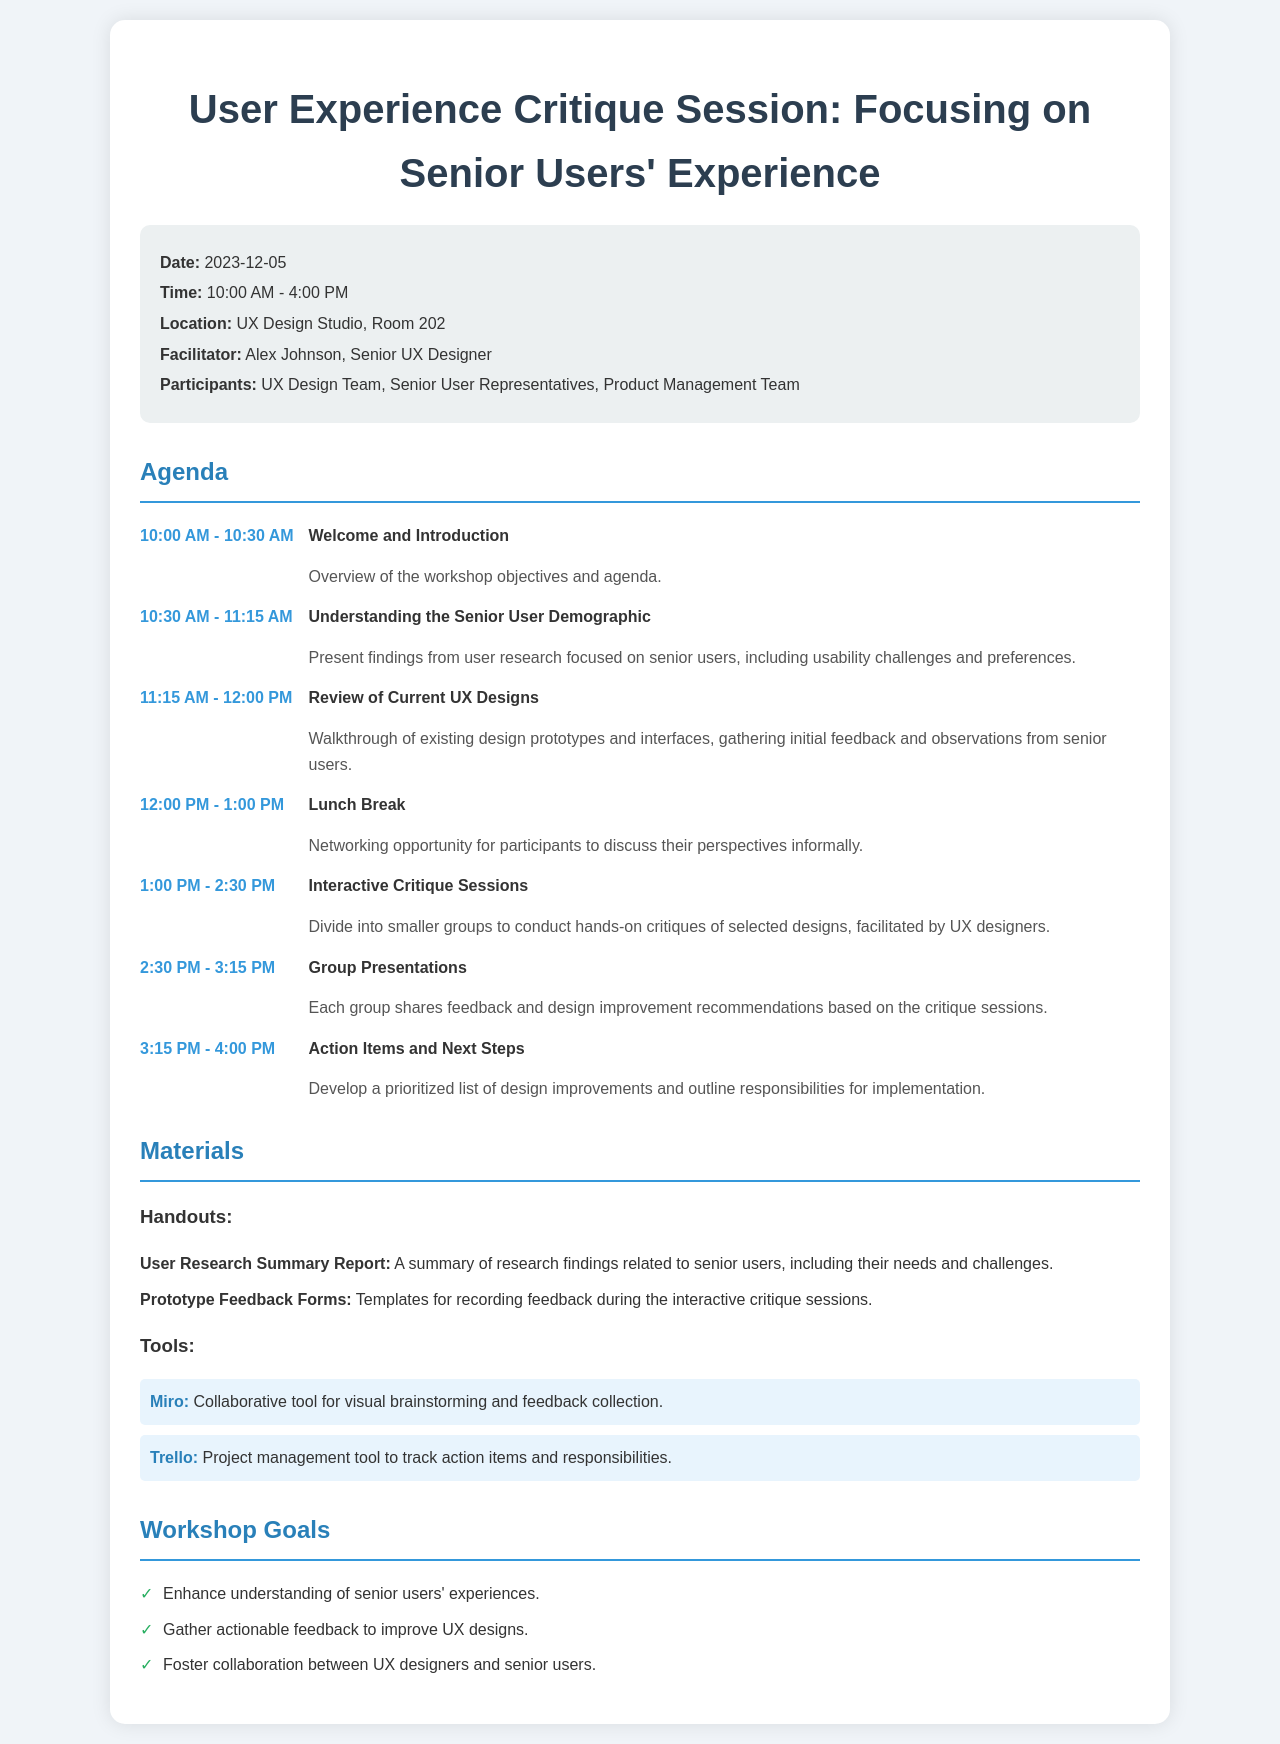what is the date of the workshop? The date of the workshop is explicitly stated in the document.
Answer: 2023-12-05 who is the facilitator of the workshop? The facilitator's name is provided within the workshop information section.
Answer: Alex Johnson what time does the workshop start? The start time of the workshop is mentioned along with the date in the document.
Answer: 10:00 AM what is the location of the workshop? The location details are outlined in the workshop information section.
Answer: UX Design Studio, Room 202 how long is the lunch break scheduled for? The length of the lunch break is specified in the agenda.
Answer: 1 hour what is one of the workshop goals? The goals of the workshop are listed in bullet points in the document.
Answer: Enhance understanding of senior users' experiences how many agenda items are there in total? The total number of agenda items can be counted from the agenda section.
Answer: 7 what tool is mentioned for collaborative feedback collection? The document lists specific tools related to the workshop, including their purposes.
Answer: Miro what activity follows the understanding the senior user demographic session? The agenda items are listed sequentially, indicating which activity comes next.
Answer: Review of Current UX Designs 